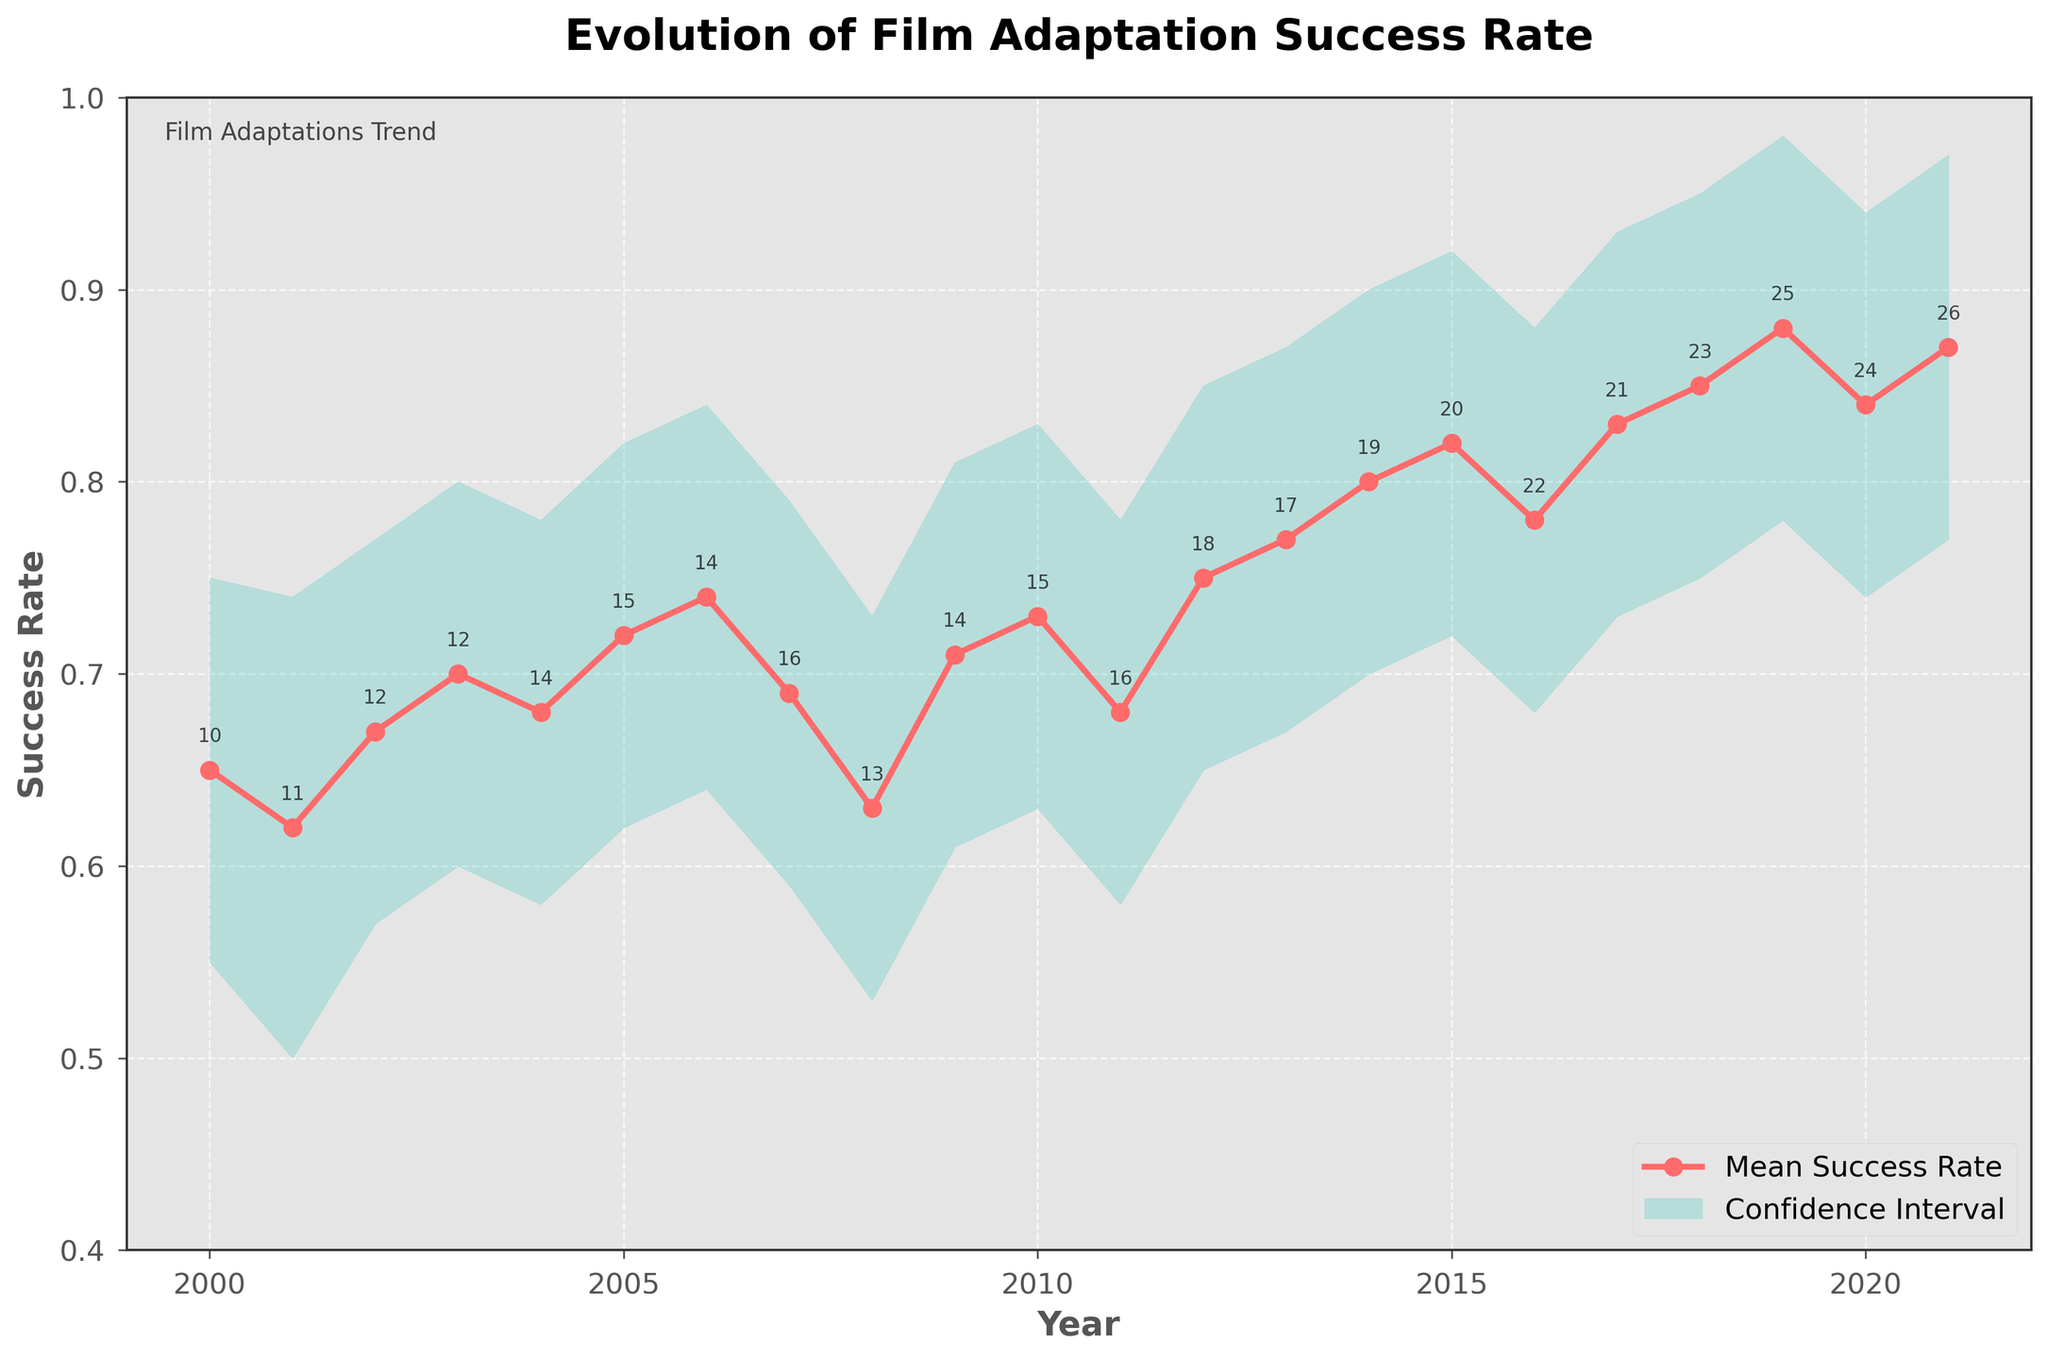What is the title of the figure? To identify the title of the figure, one simply needs to look at the top section of the plot where the title text is located.
Answer: Evolution of Film Adaptation Success Rate How many years of data are displayed in the figure? Count the number of unique years on the x-axis.
Answer: 22 What was the mean success rate of film adaptations in 2015? Locate the data point for the year 2015 on the x-axis and see where it intersects the line representing the mean success rate.
Answer: 0.82 Which year had the highest number of film adaptations? Review the number annotations above each data point along the graph and identify the highest one.
Answer: 2021 During which year did the mean success rate first reach 0.80? Trace along the line representing the mean success rate and find the first instance where it reaches or exceeds 0.80.
Answer: 2014 What is the range of the confidence intervals for the year 2018? Identify the lower and upper confidence intervals for 2018 and subtract the lower value from the upper value. 95 - 75 = 20
Answer: 20 By how much did the mean success rate change from 2008 to 2009? Calculate the difference between the mean success rate in 2009 and the mean success rate in 2008. 71 - 63 = 8
Answer: 0.08 Which year had a higher mean success rate, 2010 or 2011? Compare the data points for 2010 and 2011.
Answer: 2010 What’s the overall trend in the success rate of film adaptations from 2000 to 2021? Analyze the line plot to determine if the values generally increase, decrease, or remain constant over time.
Answer: Increasing In which range (upper or lower) did the confidence interval span the widest in 2019? Review the confidence intervals for the year 2019 and compare both ranges to determine which one is greater.
Answer: Upper range 